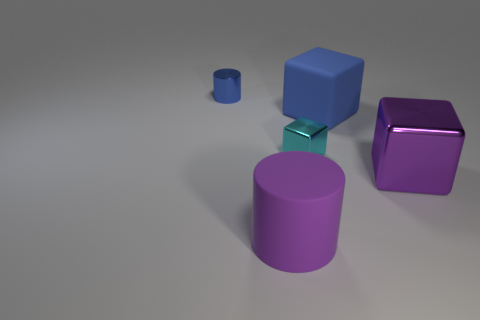How many cyan things are the same size as the metallic cylinder?
Give a very brief answer. 1. There is a rubber object behind the purple metal object; is it the same shape as the tiny metallic thing on the right side of the purple cylinder?
Provide a succinct answer. Yes. There is another big thing that is the same color as the large shiny object; what is its shape?
Keep it short and to the point. Cylinder. What color is the tiny metal object in front of the small shiny cylinder that is behind the big blue cube?
Provide a short and direct response. Cyan. There is a large matte thing that is the same shape as the tiny cyan metallic object; what is its color?
Make the answer very short. Blue. What is the size of the cyan metal object that is the same shape as the purple metal object?
Offer a terse response. Small. There is a small object that is on the right side of the tiny blue cylinder; what is it made of?
Give a very brief answer. Metal. Are there fewer big purple cubes on the left side of the big cylinder than large purple metallic blocks?
Provide a short and direct response. Yes. There is a large thing that is in front of the large metallic cube that is in front of the small blue cylinder; what shape is it?
Your answer should be very brief. Cylinder. The shiny cylinder is what color?
Make the answer very short. Blue. 